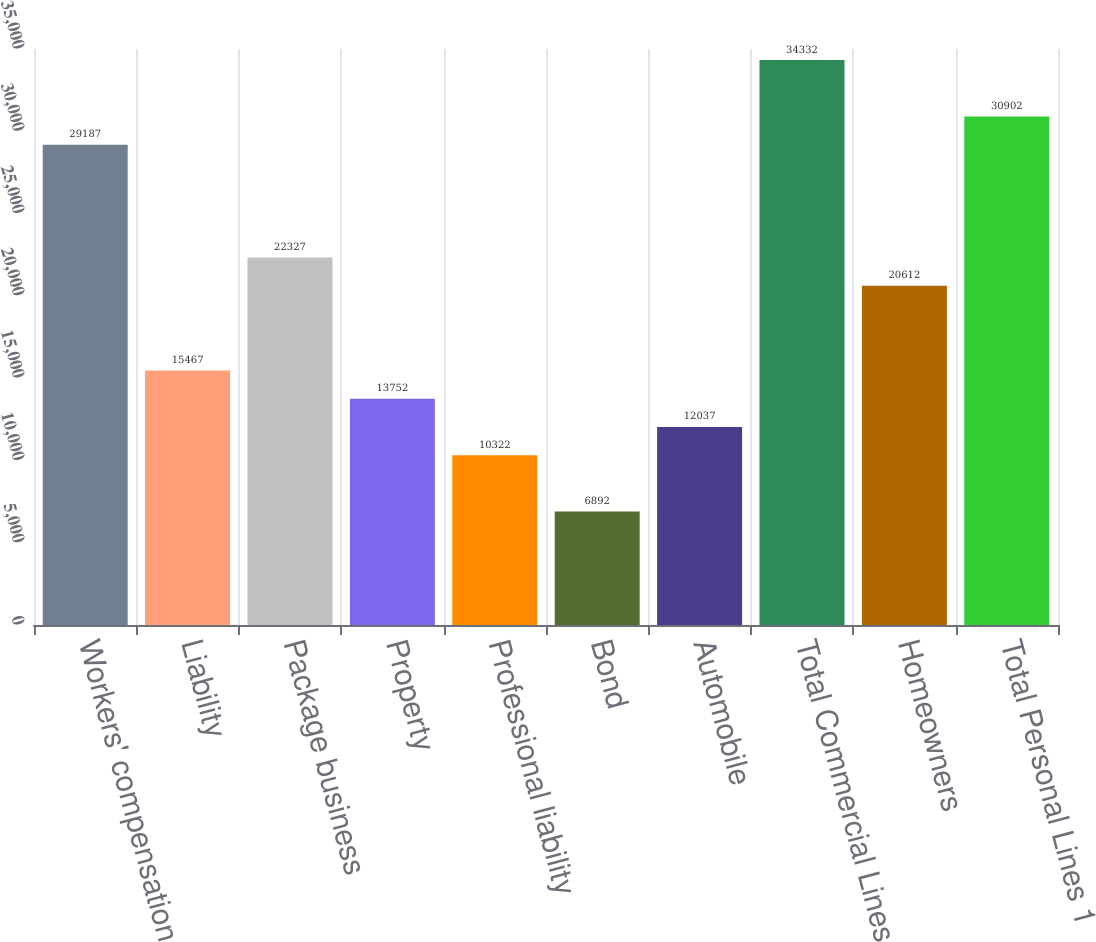Convert chart to OTSL. <chart><loc_0><loc_0><loc_500><loc_500><bar_chart><fcel>Workers' compensation<fcel>Liability<fcel>Package business<fcel>Property<fcel>Professional liability<fcel>Bond<fcel>Automobile<fcel>Total Commercial Lines<fcel>Homeowners<fcel>Total Personal Lines 1<nl><fcel>29187<fcel>15467<fcel>22327<fcel>13752<fcel>10322<fcel>6892<fcel>12037<fcel>34332<fcel>20612<fcel>30902<nl></chart> 